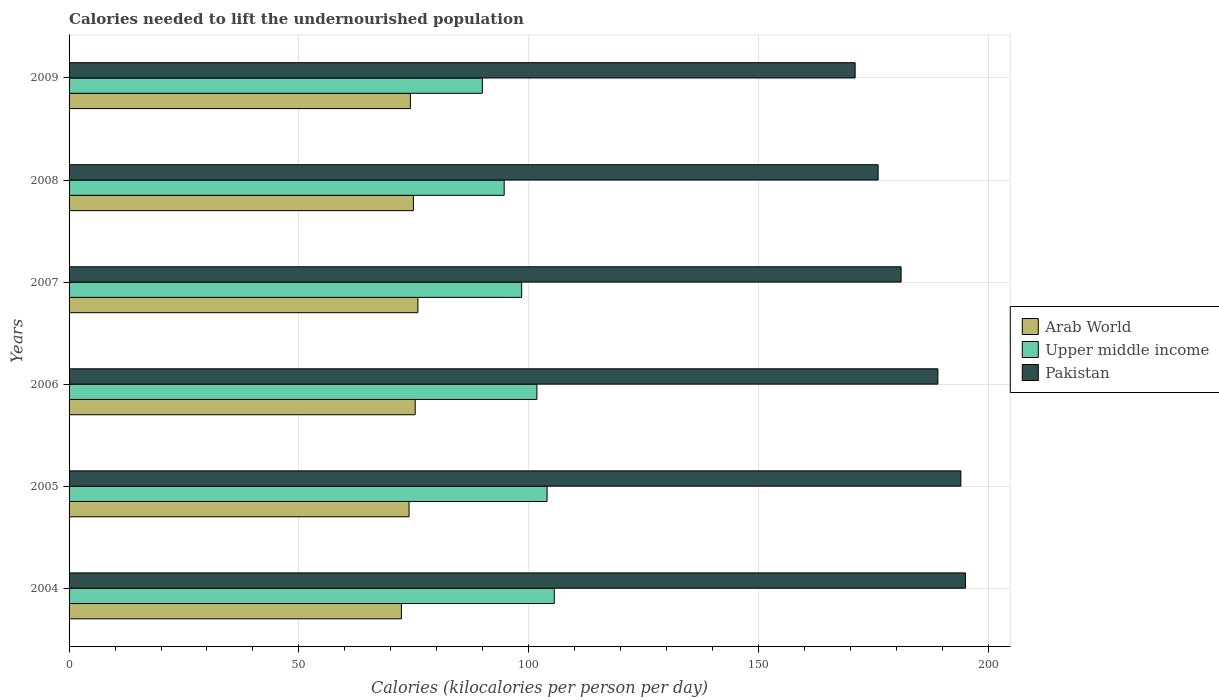What is the label of the 3rd group of bars from the top?
Provide a succinct answer. 2007. What is the total calories needed to lift the undernourished population in Upper middle income in 2007?
Give a very brief answer. 98.45. Across all years, what is the maximum total calories needed to lift the undernourished population in Upper middle income?
Provide a short and direct response. 105.55. Across all years, what is the minimum total calories needed to lift the undernourished population in Pakistan?
Make the answer very short. 171. In which year was the total calories needed to lift the undernourished population in Upper middle income maximum?
Offer a terse response. 2004. What is the total total calories needed to lift the undernourished population in Pakistan in the graph?
Provide a succinct answer. 1106. What is the difference between the total calories needed to lift the undernourished population in Upper middle income in 2005 and that in 2009?
Keep it short and to the point. 14.08. What is the difference between the total calories needed to lift the undernourished population in Pakistan in 2006 and the total calories needed to lift the undernourished population in Upper middle income in 2008?
Provide a succinct answer. 94.35. What is the average total calories needed to lift the undernourished population in Upper middle income per year?
Keep it short and to the point. 99.05. In the year 2005, what is the difference between the total calories needed to lift the undernourished population in Upper middle income and total calories needed to lift the undernourished population in Arab World?
Make the answer very short. 30.02. What is the ratio of the total calories needed to lift the undernourished population in Arab World in 2004 to that in 2009?
Your answer should be very brief. 0.97. Is the difference between the total calories needed to lift the undernourished population in Upper middle income in 2006 and 2008 greater than the difference between the total calories needed to lift the undernourished population in Arab World in 2006 and 2008?
Offer a terse response. Yes. What is the difference between the highest and the second highest total calories needed to lift the undernourished population in Upper middle income?
Keep it short and to the point. 1.57. What is the difference between the highest and the lowest total calories needed to lift the undernourished population in Upper middle income?
Provide a succinct answer. 15.65. What does the 3rd bar from the top in 2008 represents?
Keep it short and to the point. Arab World. What does the 2nd bar from the bottom in 2009 represents?
Keep it short and to the point. Upper middle income. Is it the case that in every year, the sum of the total calories needed to lift the undernourished population in Arab World and total calories needed to lift the undernourished population in Pakistan is greater than the total calories needed to lift the undernourished population in Upper middle income?
Provide a short and direct response. Yes. Are all the bars in the graph horizontal?
Ensure brevity in your answer.  Yes. How many years are there in the graph?
Give a very brief answer. 6. How many legend labels are there?
Provide a succinct answer. 3. How are the legend labels stacked?
Give a very brief answer. Vertical. What is the title of the graph?
Your response must be concise. Calories needed to lift the undernourished population. Does "Armenia" appear as one of the legend labels in the graph?
Give a very brief answer. No. What is the label or title of the X-axis?
Offer a very short reply. Calories (kilocalories per person per day). What is the Calories (kilocalories per person per day) of Arab World in 2004?
Your answer should be compact. 72.3. What is the Calories (kilocalories per person per day) in Upper middle income in 2004?
Provide a short and direct response. 105.55. What is the Calories (kilocalories per person per day) of Pakistan in 2004?
Your response must be concise. 195. What is the Calories (kilocalories per person per day) of Arab World in 2005?
Your answer should be very brief. 73.96. What is the Calories (kilocalories per person per day) of Upper middle income in 2005?
Offer a very short reply. 103.98. What is the Calories (kilocalories per person per day) in Pakistan in 2005?
Offer a very short reply. 194. What is the Calories (kilocalories per person per day) of Arab World in 2006?
Keep it short and to the point. 75.3. What is the Calories (kilocalories per person per day) of Upper middle income in 2006?
Ensure brevity in your answer.  101.77. What is the Calories (kilocalories per person per day) of Pakistan in 2006?
Offer a very short reply. 189. What is the Calories (kilocalories per person per day) of Arab World in 2007?
Provide a short and direct response. 75.88. What is the Calories (kilocalories per person per day) of Upper middle income in 2007?
Make the answer very short. 98.45. What is the Calories (kilocalories per person per day) in Pakistan in 2007?
Your answer should be compact. 181. What is the Calories (kilocalories per person per day) in Arab World in 2008?
Make the answer very short. 74.9. What is the Calories (kilocalories per person per day) of Upper middle income in 2008?
Provide a succinct answer. 94.65. What is the Calories (kilocalories per person per day) in Pakistan in 2008?
Ensure brevity in your answer.  176. What is the Calories (kilocalories per person per day) in Arab World in 2009?
Your response must be concise. 74.25. What is the Calories (kilocalories per person per day) of Upper middle income in 2009?
Your response must be concise. 89.9. What is the Calories (kilocalories per person per day) in Pakistan in 2009?
Keep it short and to the point. 171. Across all years, what is the maximum Calories (kilocalories per person per day) of Arab World?
Offer a terse response. 75.88. Across all years, what is the maximum Calories (kilocalories per person per day) in Upper middle income?
Give a very brief answer. 105.55. Across all years, what is the maximum Calories (kilocalories per person per day) of Pakistan?
Provide a short and direct response. 195. Across all years, what is the minimum Calories (kilocalories per person per day) in Arab World?
Your response must be concise. 72.3. Across all years, what is the minimum Calories (kilocalories per person per day) in Upper middle income?
Ensure brevity in your answer.  89.9. Across all years, what is the minimum Calories (kilocalories per person per day) of Pakistan?
Give a very brief answer. 171. What is the total Calories (kilocalories per person per day) of Arab World in the graph?
Offer a very short reply. 446.59. What is the total Calories (kilocalories per person per day) in Upper middle income in the graph?
Offer a very short reply. 594.31. What is the total Calories (kilocalories per person per day) of Pakistan in the graph?
Provide a succinct answer. 1106. What is the difference between the Calories (kilocalories per person per day) in Arab World in 2004 and that in 2005?
Provide a succinct answer. -1.66. What is the difference between the Calories (kilocalories per person per day) of Upper middle income in 2004 and that in 2005?
Make the answer very short. 1.57. What is the difference between the Calories (kilocalories per person per day) of Arab World in 2004 and that in 2006?
Make the answer very short. -3. What is the difference between the Calories (kilocalories per person per day) in Upper middle income in 2004 and that in 2006?
Provide a succinct answer. 3.78. What is the difference between the Calories (kilocalories per person per day) in Arab World in 2004 and that in 2007?
Ensure brevity in your answer.  -3.59. What is the difference between the Calories (kilocalories per person per day) in Upper middle income in 2004 and that in 2007?
Provide a short and direct response. 7.1. What is the difference between the Calories (kilocalories per person per day) of Arab World in 2004 and that in 2008?
Your answer should be compact. -2.61. What is the difference between the Calories (kilocalories per person per day) of Upper middle income in 2004 and that in 2008?
Offer a very short reply. 10.9. What is the difference between the Calories (kilocalories per person per day) in Pakistan in 2004 and that in 2008?
Ensure brevity in your answer.  19. What is the difference between the Calories (kilocalories per person per day) of Arab World in 2004 and that in 2009?
Ensure brevity in your answer.  -1.95. What is the difference between the Calories (kilocalories per person per day) in Upper middle income in 2004 and that in 2009?
Provide a succinct answer. 15.65. What is the difference between the Calories (kilocalories per person per day) of Pakistan in 2004 and that in 2009?
Your answer should be very brief. 24. What is the difference between the Calories (kilocalories per person per day) of Arab World in 2005 and that in 2006?
Offer a very short reply. -1.34. What is the difference between the Calories (kilocalories per person per day) in Upper middle income in 2005 and that in 2006?
Provide a succinct answer. 2.21. What is the difference between the Calories (kilocalories per person per day) in Arab World in 2005 and that in 2007?
Provide a succinct answer. -1.93. What is the difference between the Calories (kilocalories per person per day) of Upper middle income in 2005 and that in 2007?
Keep it short and to the point. 5.53. What is the difference between the Calories (kilocalories per person per day) in Pakistan in 2005 and that in 2007?
Your response must be concise. 13. What is the difference between the Calories (kilocalories per person per day) in Arab World in 2005 and that in 2008?
Your response must be concise. -0.95. What is the difference between the Calories (kilocalories per person per day) of Upper middle income in 2005 and that in 2008?
Make the answer very short. 9.33. What is the difference between the Calories (kilocalories per person per day) in Arab World in 2005 and that in 2009?
Provide a short and direct response. -0.3. What is the difference between the Calories (kilocalories per person per day) of Upper middle income in 2005 and that in 2009?
Offer a very short reply. 14.08. What is the difference between the Calories (kilocalories per person per day) in Pakistan in 2005 and that in 2009?
Offer a terse response. 23. What is the difference between the Calories (kilocalories per person per day) in Arab World in 2006 and that in 2007?
Your answer should be compact. -0.59. What is the difference between the Calories (kilocalories per person per day) of Upper middle income in 2006 and that in 2007?
Provide a short and direct response. 3.32. What is the difference between the Calories (kilocalories per person per day) in Pakistan in 2006 and that in 2007?
Provide a succinct answer. 8. What is the difference between the Calories (kilocalories per person per day) of Arab World in 2006 and that in 2008?
Your answer should be very brief. 0.39. What is the difference between the Calories (kilocalories per person per day) of Upper middle income in 2006 and that in 2008?
Provide a succinct answer. 7.12. What is the difference between the Calories (kilocalories per person per day) in Arab World in 2006 and that in 2009?
Provide a succinct answer. 1.04. What is the difference between the Calories (kilocalories per person per day) of Upper middle income in 2006 and that in 2009?
Offer a terse response. 11.87. What is the difference between the Calories (kilocalories per person per day) of Arab World in 2007 and that in 2008?
Give a very brief answer. 0.98. What is the difference between the Calories (kilocalories per person per day) of Upper middle income in 2007 and that in 2008?
Offer a very short reply. 3.8. What is the difference between the Calories (kilocalories per person per day) in Arab World in 2007 and that in 2009?
Offer a terse response. 1.63. What is the difference between the Calories (kilocalories per person per day) of Upper middle income in 2007 and that in 2009?
Offer a terse response. 8.56. What is the difference between the Calories (kilocalories per person per day) of Pakistan in 2007 and that in 2009?
Make the answer very short. 10. What is the difference between the Calories (kilocalories per person per day) in Arab World in 2008 and that in 2009?
Offer a very short reply. 0.65. What is the difference between the Calories (kilocalories per person per day) of Upper middle income in 2008 and that in 2009?
Give a very brief answer. 4.75. What is the difference between the Calories (kilocalories per person per day) of Arab World in 2004 and the Calories (kilocalories per person per day) of Upper middle income in 2005?
Your answer should be very brief. -31.68. What is the difference between the Calories (kilocalories per person per day) of Arab World in 2004 and the Calories (kilocalories per person per day) of Pakistan in 2005?
Offer a very short reply. -121.7. What is the difference between the Calories (kilocalories per person per day) of Upper middle income in 2004 and the Calories (kilocalories per person per day) of Pakistan in 2005?
Offer a terse response. -88.45. What is the difference between the Calories (kilocalories per person per day) of Arab World in 2004 and the Calories (kilocalories per person per day) of Upper middle income in 2006?
Ensure brevity in your answer.  -29.48. What is the difference between the Calories (kilocalories per person per day) of Arab World in 2004 and the Calories (kilocalories per person per day) of Pakistan in 2006?
Provide a short and direct response. -116.7. What is the difference between the Calories (kilocalories per person per day) in Upper middle income in 2004 and the Calories (kilocalories per person per day) in Pakistan in 2006?
Your answer should be very brief. -83.45. What is the difference between the Calories (kilocalories per person per day) of Arab World in 2004 and the Calories (kilocalories per person per day) of Upper middle income in 2007?
Provide a succinct answer. -26.16. What is the difference between the Calories (kilocalories per person per day) of Arab World in 2004 and the Calories (kilocalories per person per day) of Pakistan in 2007?
Offer a very short reply. -108.7. What is the difference between the Calories (kilocalories per person per day) in Upper middle income in 2004 and the Calories (kilocalories per person per day) in Pakistan in 2007?
Keep it short and to the point. -75.45. What is the difference between the Calories (kilocalories per person per day) of Arab World in 2004 and the Calories (kilocalories per person per day) of Upper middle income in 2008?
Offer a very short reply. -22.35. What is the difference between the Calories (kilocalories per person per day) in Arab World in 2004 and the Calories (kilocalories per person per day) in Pakistan in 2008?
Make the answer very short. -103.7. What is the difference between the Calories (kilocalories per person per day) in Upper middle income in 2004 and the Calories (kilocalories per person per day) in Pakistan in 2008?
Ensure brevity in your answer.  -70.45. What is the difference between the Calories (kilocalories per person per day) in Arab World in 2004 and the Calories (kilocalories per person per day) in Upper middle income in 2009?
Keep it short and to the point. -17.6. What is the difference between the Calories (kilocalories per person per day) of Arab World in 2004 and the Calories (kilocalories per person per day) of Pakistan in 2009?
Give a very brief answer. -98.7. What is the difference between the Calories (kilocalories per person per day) of Upper middle income in 2004 and the Calories (kilocalories per person per day) of Pakistan in 2009?
Make the answer very short. -65.45. What is the difference between the Calories (kilocalories per person per day) of Arab World in 2005 and the Calories (kilocalories per person per day) of Upper middle income in 2006?
Your answer should be compact. -27.82. What is the difference between the Calories (kilocalories per person per day) of Arab World in 2005 and the Calories (kilocalories per person per day) of Pakistan in 2006?
Offer a very short reply. -115.04. What is the difference between the Calories (kilocalories per person per day) in Upper middle income in 2005 and the Calories (kilocalories per person per day) in Pakistan in 2006?
Ensure brevity in your answer.  -85.02. What is the difference between the Calories (kilocalories per person per day) of Arab World in 2005 and the Calories (kilocalories per person per day) of Upper middle income in 2007?
Your answer should be very brief. -24.5. What is the difference between the Calories (kilocalories per person per day) in Arab World in 2005 and the Calories (kilocalories per person per day) in Pakistan in 2007?
Ensure brevity in your answer.  -107.04. What is the difference between the Calories (kilocalories per person per day) of Upper middle income in 2005 and the Calories (kilocalories per person per day) of Pakistan in 2007?
Your answer should be compact. -77.02. What is the difference between the Calories (kilocalories per person per day) in Arab World in 2005 and the Calories (kilocalories per person per day) in Upper middle income in 2008?
Offer a very short reply. -20.69. What is the difference between the Calories (kilocalories per person per day) of Arab World in 2005 and the Calories (kilocalories per person per day) of Pakistan in 2008?
Provide a short and direct response. -102.04. What is the difference between the Calories (kilocalories per person per day) of Upper middle income in 2005 and the Calories (kilocalories per person per day) of Pakistan in 2008?
Make the answer very short. -72.02. What is the difference between the Calories (kilocalories per person per day) of Arab World in 2005 and the Calories (kilocalories per person per day) of Upper middle income in 2009?
Your answer should be compact. -15.94. What is the difference between the Calories (kilocalories per person per day) of Arab World in 2005 and the Calories (kilocalories per person per day) of Pakistan in 2009?
Your response must be concise. -97.04. What is the difference between the Calories (kilocalories per person per day) in Upper middle income in 2005 and the Calories (kilocalories per person per day) in Pakistan in 2009?
Ensure brevity in your answer.  -67.02. What is the difference between the Calories (kilocalories per person per day) of Arab World in 2006 and the Calories (kilocalories per person per day) of Upper middle income in 2007?
Ensure brevity in your answer.  -23.16. What is the difference between the Calories (kilocalories per person per day) in Arab World in 2006 and the Calories (kilocalories per person per day) in Pakistan in 2007?
Offer a very short reply. -105.7. What is the difference between the Calories (kilocalories per person per day) of Upper middle income in 2006 and the Calories (kilocalories per person per day) of Pakistan in 2007?
Keep it short and to the point. -79.23. What is the difference between the Calories (kilocalories per person per day) in Arab World in 2006 and the Calories (kilocalories per person per day) in Upper middle income in 2008?
Provide a short and direct response. -19.36. What is the difference between the Calories (kilocalories per person per day) in Arab World in 2006 and the Calories (kilocalories per person per day) in Pakistan in 2008?
Ensure brevity in your answer.  -100.7. What is the difference between the Calories (kilocalories per person per day) in Upper middle income in 2006 and the Calories (kilocalories per person per day) in Pakistan in 2008?
Ensure brevity in your answer.  -74.23. What is the difference between the Calories (kilocalories per person per day) in Arab World in 2006 and the Calories (kilocalories per person per day) in Upper middle income in 2009?
Offer a very short reply. -14.6. What is the difference between the Calories (kilocalories per person per day) of Arab World in 2006 and the Calories (kilocalories per person per day) of Pakistan in 2009?
Your answer should be compact. -95.7. What is the difference between the Calories (kilocalories per person per day) in Upper middle income in 2006 and the Calories (kilocalories per person per day) in Pakistan in 2009?
Your answer should be compact. -69.23. What is the difference between the Calories (kilocalories per person per day) in Arab World in 2007 and the Calories (kilocalories per person per day) in Upper middle income in 2008?
Ensure brevity in your answer.  -18.77. What is the difference between the Calories (kilocalories per person per day) in Arab World in 2007 and the Calories (kilocalories per person per day) in Pakistan in 2008?
Give a very brief answer. -100.12. What is the difference between the Calories (kilocalories per person per day) in Upper middle income in 2007 and the Calories (kilocalories per person per day) in Pakistan in 2008?
Provide a succinct answer. -77.55. What is the difference between the Calories (kilocalories per person per day) of Arab World in 2007 and the Calories (kilocalories per person per day) of Upper middle income in 2009?
Offer a terse response. -14.02. What is the difference between the Calories (kilocalories per person per day) in Arab World in 2007 and the Calories (kilocalories per person per day) in Pakistan in 2009?
Your response must be concise. -95.12. What is the difference between the Calories (kilocalories per person per day) in Upper middle income in 2007 and the Calories (kilocalories per person per day) in Pakistan in 2009?
Provide a short and direct response. -72.55. What is the difference between the Calories (kilocalories per person per day) in Arab World in 2008 and the Calories (kilocalories per person per day) in Upper middle income in 2009?
Provide a succinct answer. -14.99. What is the difference between the Calories (kilocalories per person per day) of Arab World in 2008 and the Calories (kilocalories per person per day) of Pakistan in 2009?
Give a very brief answer. -96.1. What is the difference between the Calories (kilocalories per person per day) of Upper middle income in 2008 and the Calories (kilocalories per person per day) of Pakistan in 2009?
Offer a very short reply. -76.35. What is the average Calories (kilocalories per person per day) in Arab World per year?
Keep it short and to the point. 74.43. What is the average Calories (kilocalories per person per day) in Upper middle income per year?
Your response must be concise. 99.05. What is the average Calories (kilocalories per person per day) in Pakistan per year?
Provide a succinct answer. 184.33. In the year 2004, what is the difference between the Calories (kilocalories per person per day) of Arab World and Calories (kilocalories per person per day) of Upper middle income?
Ensure brevity in your answer.  -33.25. In the year 2004, what is the difference between the Calories (kilocalories per person per day) in Arab World and Calories (kilocalories per person per day) in Pakistan?
Your answer should be compact. -122.7. In the year 2004, what is the difference between the Calories (kilocalories per person per day) in Upper middle income and Calories (kilocalories per person per day) in Pakistan?
Your answer should be compact. -89.45. In the year 2005, what is the difference between the Calories (kilocalories per person per day) of Arab World and Calories (kilocalories per person per day) of Upper middle income?
Keep it short and to the point. -30.02. In the year 2005, what is the difference between the Calories (kilocalories per person per day) of Arab World and Calories (kilocalories per person per day) of Pakistan?
Make the answer very short. -120.04. In the year 2005, what is the difference between the Calories (kilocalories per person per day) in Upper middle income and Calories (kilocalories per person per day) in Pakistan?
Keep it short and to the point. -90.02. In the year 2006, what is the difference between the Calories (kilocalories per person per day) of Arab World and Calories (kilocalories per person per day) of Upper middle income?
Your answer should be very brief. -26.48. In the year 2006, what is the difference between the Calories (kilocalories per person per day) of Arab World and Calories (kilocalories per person per day) of Pakistan?
Provide a succinct answer. -113.7. In the year 2006, what is the difference between the Calories (kilocalories per person per day) of Upper middle income and Calories (kilocalories per person per day) of Pakistan?
Make the answer very short. -87.23. In the year 2007, what is the difference between the Calories (kilocalories per person per day) in Arab World and Calories (kilocalories per person per day) in Upper middle income?
Your response must be concise. -22.57. In the year 2007, what is the difference between the Calories (kilocalories per person per day) of Arab World and Calories (kilocalories per person per day) of Pakistan?
Give a very brief answer. -105.12. In the year 2007, what is the difference between the Calories (kilocalories per person per day) in Upper middle income and Calories (kilocalories per person per day) in Pakistan?
Your answer should be very brief. -82.55. In the year 2008, what is the difference between the Calories (kilocalories per person per day) of Arab World and Calories (kilocalories per person per day) of Upper middle income?
Offer a very short reply. -19.75. In the year 2008, what is the difference between the Calories (kilocalories per person per day) of Arab World and Calories (kilocalories per person per day) of Pakistan?
Keep it short and to the point. -101.1. In the year 2008, what is the difference between the Calories (kilocalories per person per day) of Upper middle income and Calories (kilocalories per person per day) of Pakistan?
Your answer should be very brief. -81.35. In the year 2009, what is the difference between the Calories (kilocalories per person per day) of Arab World and Calories (kilocalories per person per day) of Upper middle income?
Offer a terse response. -15.65. In the year 2009, what is the difference between the Calories (kilocalories per person per day) in Arab World and Calories (kilocalories per person per day) in Pakistan?
Your answer should be very brief. -96.75. In the year 2009, what is the difference between the Calories (kilocalories per person per day) in Upper middle income and Calories (kilocalories per person per day) in Pakistan?
Your answer should be very brief. -81.1. What is the ratio of the Calories (kilocalories per person per day) in Arab World in 2004 to that in 2005?
Give a very brief answer. 0.98. What is the ratio of the Calories (kilocalories per person per day) in Upper middle income in 2004 to that in 2005?
Ensure brevity in your answer.  1.02. What is the ratio of the Calories (kilocalories per person per day) of Arab World in 2004 to that in 2006?
Ensure brevity in your answer.  0.96. What is the ratio of the Calories (kilocalories per person per day) in Upper middle income in 2004 to that in 2006?
Your answer should be compact. 1.04. What is the ratio of the Calories (kilocalories per person per day) in Pakistan in 2004 to that in 2006?
Provide a short and direct response. 1.03. What is the ratio of the Calories (kilocalories per person per day) of Arab World in 2004 to that in 2007?
Your answer should be very brief. 0.95. What is the ratio of the Calories (kilocalories per person per day) of Upper middle income in 2004 to that in 2007?
Offer a terse response. 1.07. What is the ratio of the Calories (kilocalories per person per day) in Pakistan in 2004 to that in 2007?
Your response must be concise. 1.08. What is the ratio of the Calories (kilocalories per person per day) in Arab World in 2004 to that in 2008?
Offer a very short reply. 0.97. What is the ratio of the Calories (kilocalories per person per day) of Upper middle income in 2004 to that in 2008?
Provide a short and direct response. 1.12. What is the ratio of the Calories (kilocalories per person per day) in Pakistan in 2004 to that in 2008?
Offer a terse response. 1.11. What is the ratio of the Calories (kilocalories per person per day) in Arab World in 2004 to that in 2009?
Give a very brief answer. 0.97. What is the ratio of the Calories (kilocalories per person per day) of Upper middle income in 2004 to that in 2009?
Your answer should be compact. 1.17. What is the ratio of the Calories (kilocalories per person per day) in Pakistan in 2004 to that in 2009?
Make the answer very short. 1.14. What is the ratio of the Calories (kilocalories per person per day) in Arab World in 2005 to that in 2006?
Provide a short and direct response. 0.98. What is the ratio of the Calories (kilocalories per person per day) in Upper middle income in 2005 to that in 2006?
Your response must be concise. 1.02. What is the ratio of the Calories (kilocalories per person per day) in Pakistan in 2005 to that in 2006?
Provide a succinct answer. 1.03. What is the ratio of the Calories (kilocalories per person per day) in Arab World in 2005 to that in 2007?
Offer a very short reply. 0.97. What is the ratio of the Calories (kilocalories per person per day) in Upper middle income in 2005 to that in 2007?
Make the answer very short. 1.06. What is the ratio of the Calories (kilocalories per person per day) in Pakistan in 2005 to that in 2007?
Your response must be concise. 1.07. What is the ratio of the Calories (kilocalories per person per day) of Arab World in 2005 to that in 2008?
Provide a short and direct response. 0.99. What is the ratio of the Calories (kilocalories per person per day) of Upper middle income in 2005 to that in 2008?
Offer a very short reply. 1.1. What is the ratio of the Calories (kilocalories per person per day) of Pakistan in 2005 to that in 2008?
Offer a very short reply. 1.1. What is the ratio of the Calories (kilocalories per person per day) of Arab World in 2005 to that in 2009?
Make the answer very short. 1. What is the ratio of the Calories (kilocalories per person per day) in Upper middle income in 2005 to that in 2009?
Your response must be concise. 1.16. What is the ratio of the Calories (kilocalories per person per day) of Pakistan in 2005 to that in 2009?
Ensure brevity in your answer.  1.13. What is the ratio of the Calories (kilocalories per person per day) in Arab World in 2006 to that in 2007?
Offer a terse response. 0.99. What is the ratio of the Calories (kilocalories per person per day) of Upper middle income in 2006 to that in 2007?
Your answer should be very brief. 1.03. What is the ratio of the Calories (kilocalories per person per day) in Pakistan in 2006 to that in 2007?
Give a very brief answer. 1.04. What is the ratio of the Calories (kilocalories per person per day) of Upper middle income in 2006 to that in 2008?
Your answer should be compact. 1.08. What is the ratio of the Calories (kilocalories per person per day) of Pakistan in 2006 to that in 2008?
Make the answer very short. 1.07. What is the ratio of the Calories (kilocalories per person per day) in Upper middle income in 2006 to that in 2009?
Provide a short and direct response. 1.13. What is the ratio of the Calories (kilocalories per person per day) of Pakistan in 2006 to that in 2009?
Make the answer very short. 1.11. What is the ratio of the Calories (kilocalories per person per day) of Arab World in 2007 to that in 2008?
Offer a terse response. 1.01. What is the ratio of the Calories (kilocalories per person per day) in Upper middle income in 2007 to that in 2008?
Give a very brief answer. 1.04. What is the ratio of the Calories (kilocalories per person per day) of Pakistan in 2007 to that in 2008?
Your answer should be compact. 1.03. What is the ratio of the Calories (kilocalories per person per day) of Upper middle income in 2007 to that in 2009?
Provide a short and direct response. 1.1. What is the ratio of the Calories (kilocalories per person per day) in Pakistan in 2007 to that in 2009?
Make the answer very short. 1.06. What is the ratio of the Calories (kilocalories per person per day) of Arab World in 2008 to that in 2009?
Provide a short and direct response. 1.01. What is the ratio of the Calories (kilocalories per person per day) in Upper middle income in 2008 to that in 2009?
Make the answer very short. 1.05. What is the ratio of the Calories (kilocalories per person per day) of Pakistan in 2008 to that in 2009?
Offer a very short reply. 1.03. What is the difference between the highest and the second highest Calories (kilocalories per person per day) in Arab World?
Ensure brevity in your answer.  0.59. What is the difference between the highest and the second highest Calories (kilocalories per person per day) of Upper middle income?
Ensure brevity in your answer.  1.57. What is the difference between the highest and the lowest Calories (kilocalories per person per day) in Arab World?
Keep it short and to the point. 3.59. What is the difference between the highest and the lowest Calories (kilocalories per person per day) in Upper middle income?
Provide a short and direct response. 15.65. What is the difference between the highest and the lowest Calories (kilocalories per person per day) of Pakistan?
Offer a very short reply. 24. 